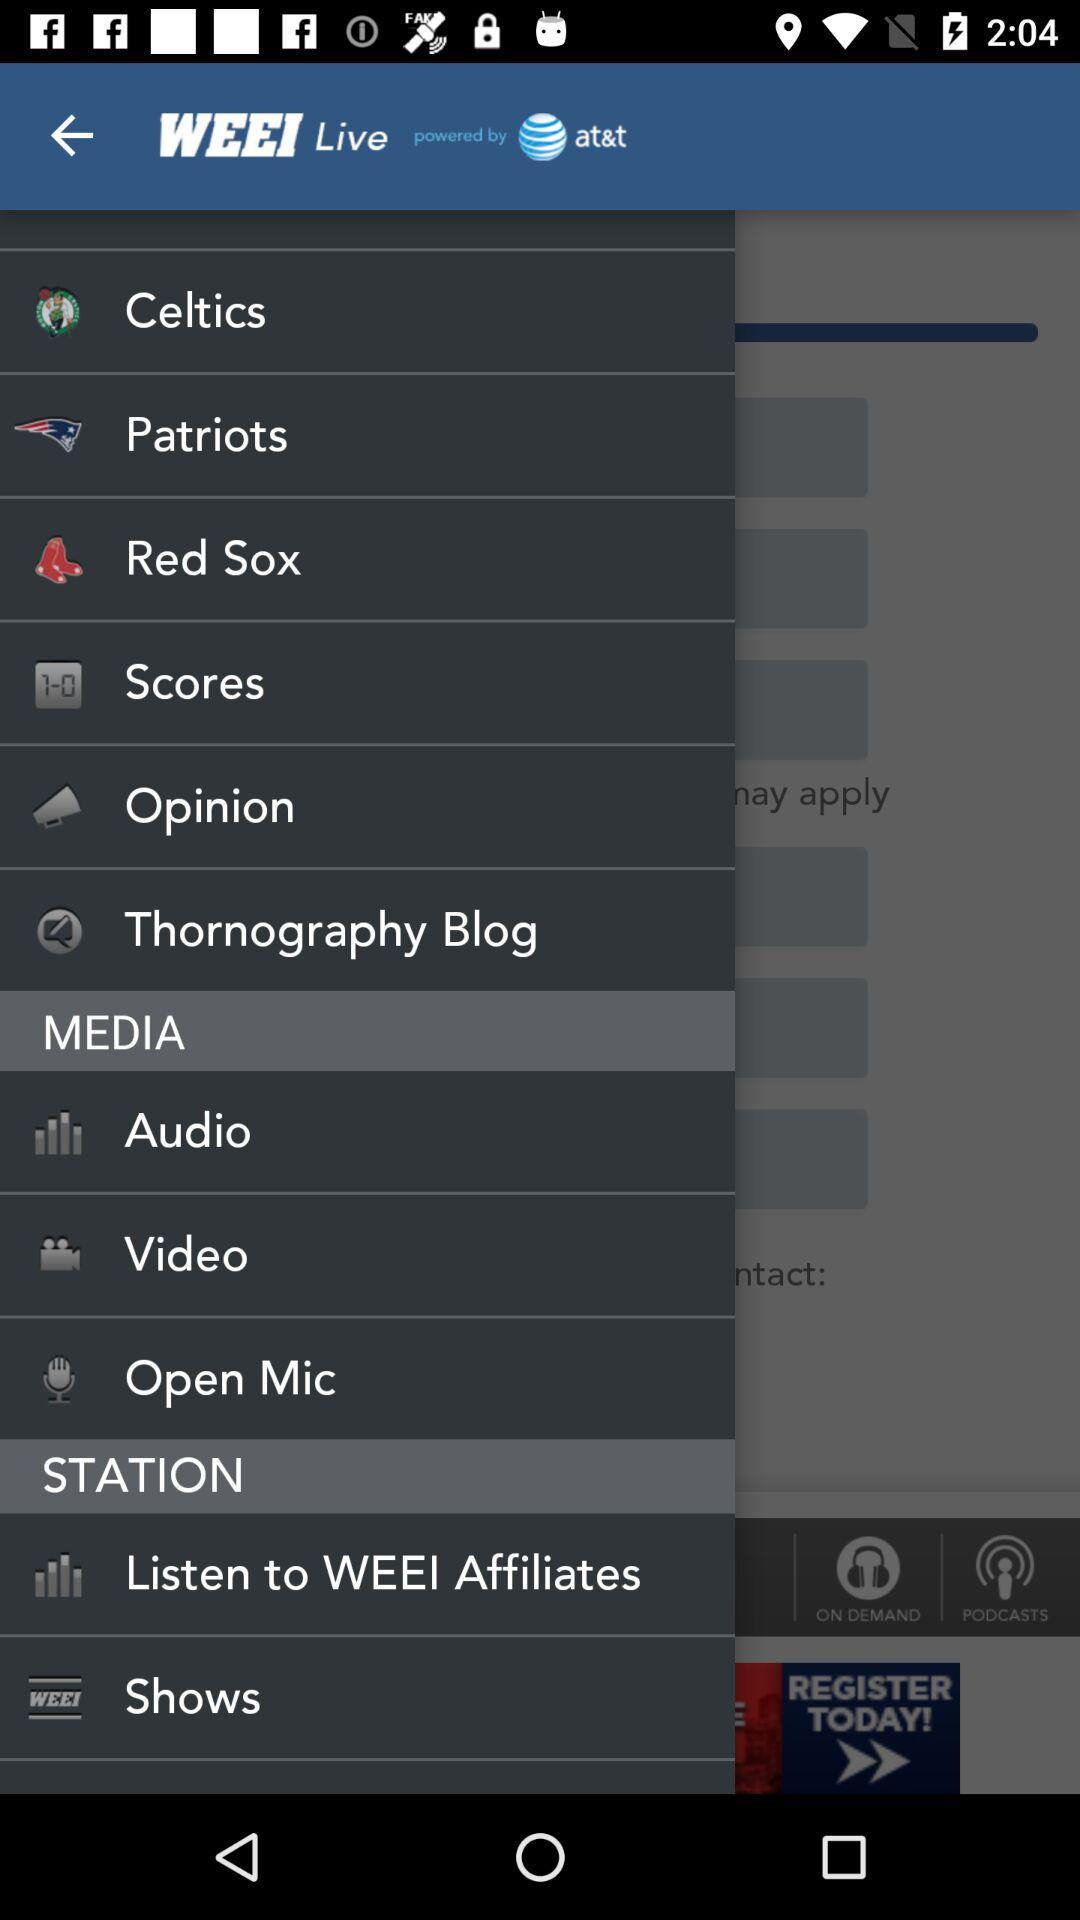What is the name of the application? The name of the application is "WEEI Live". 